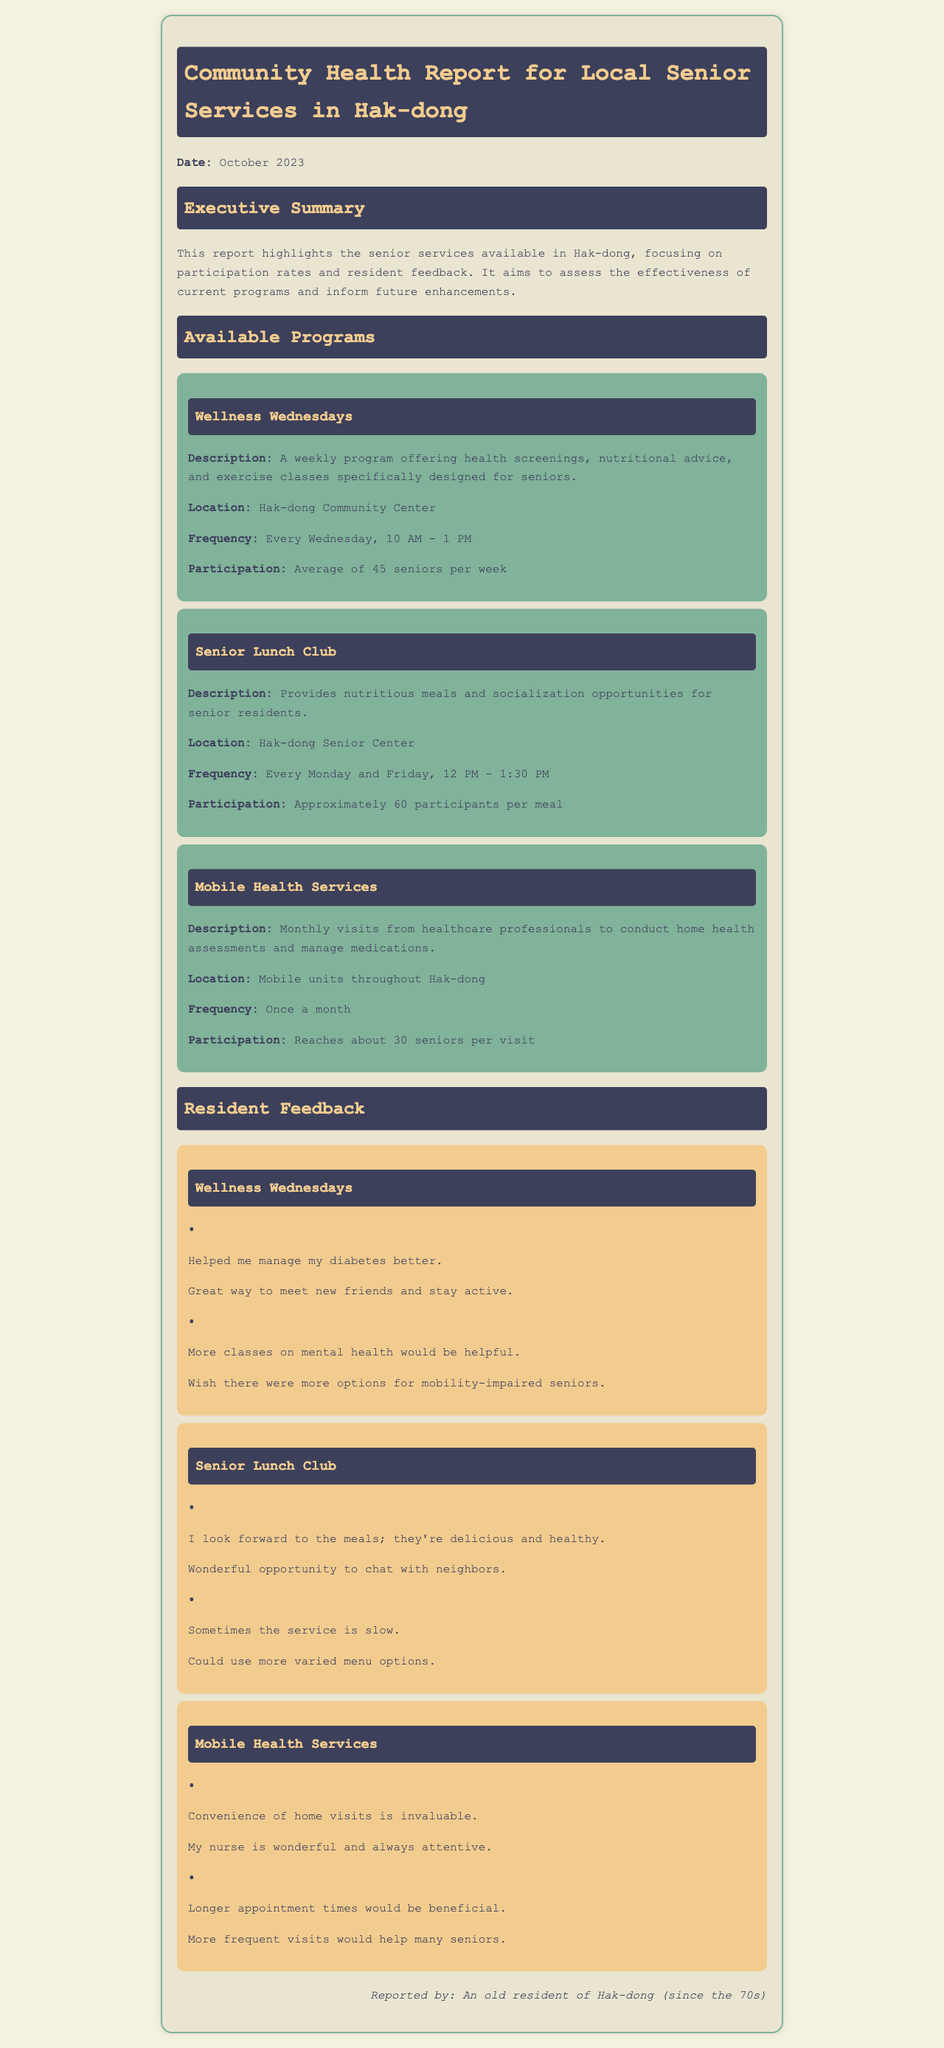What is the date of the report? The date is mentioned at the start of the report as October 2023.
Answer: October 2023 How often is the Senior Lunch Club held? The frequency of the Senior Lunch Club is specified as every Monday and Friday.
Answer: Every Monday and Friday What is the average participation in the Wellness Wednesdays program? The document states that the average participation is 45 seniors per week for Wellness Wednesdays.
Answer: 45 seniors Where is the Mobile Health Services program conducted? The location for Mobile Health Services is described as mobile units throughout Hak-dong.
Answer: Mobile units throughout Hak-dong Which program offers home health assessments? The program that provides home health assessments, as detailed in the report, is the Mobile Health Services.
Answer: Mobile Health Services What feedback is given regarding the Senior Lunch Club menu? Residents suggested that the Senior Lunch Club could use more varied menu options, which shows their desires for improvement.
Answer: More varied menu options How many seniors are reached during the Mobile Health Services per visit? The document specifies that approximately 30 seniors are reached during each visit of the Mobile Health Services.
Answer: Approximately 30 seniors What positive feedback was given about Wellness Wednesdays? Positive feedback included mentions that it helped manage diabetes and was a great way to meet friends.
Answer: Helped me manage my diabetes better What is the weekly schedule for Wellness Wednesdays? The report states that Wellness Wednesdays are held every Wednesday from 10 AM to 1 PM.
Answer: Every Wednesday, 10 AM - 1 PM 